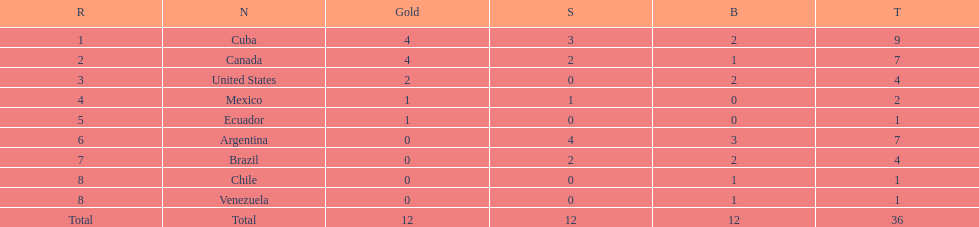In which position does mexico rank? 4. 